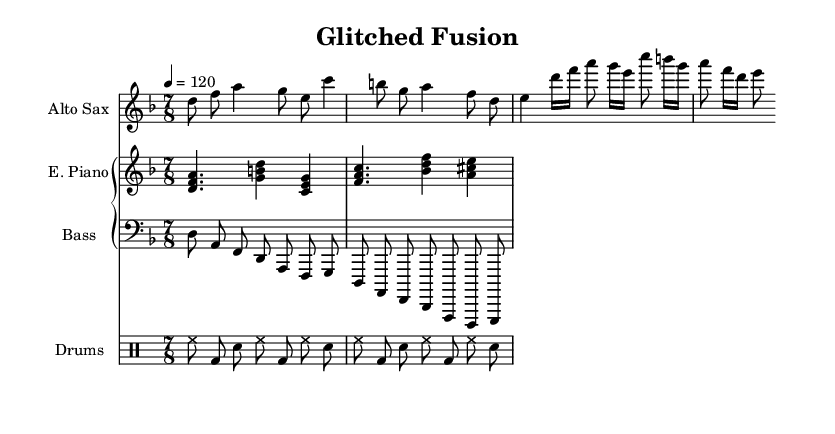What is the key signature of this music? The key signature is indicated at the beginning of the score and shows two flats, which corresponds to D minor.
Answer: D minor What is the time signature of this music? The time signature, located near the beginning of the score, is 7/8, meaning there are seven eighth notes per measure.
Answer: 7/8 What is the tempo marking of this piece? The tempo marking is listed at the start of the score as a metronome marking of 120 beats per minute.
Answer: 120 Which instrument plays the rhythm section? The rhythm section in this score is indicated by a specific staff labeled "Drums," which includes patterns for kick, snare, and hi-hat.
Answer: Drums How many measures does the saxophone part have? Counting the measures in the saxophone part reveals four distinct measures represented in the music notation.
Answer: 4 What is the defined rhythmic feel of the first bass measure? The first measure of the bass consists of a sequence of eighth notes that create a syncopated rhythmic feel consistent with jazz fusion style.
Answer: Syncopated What element reflects the experimental nature of this music? The score features irregular time signatures and complex chord structures, characteristic of avant-garde jazz and experimental fusion styles.
Answer: Irregular time signatures 